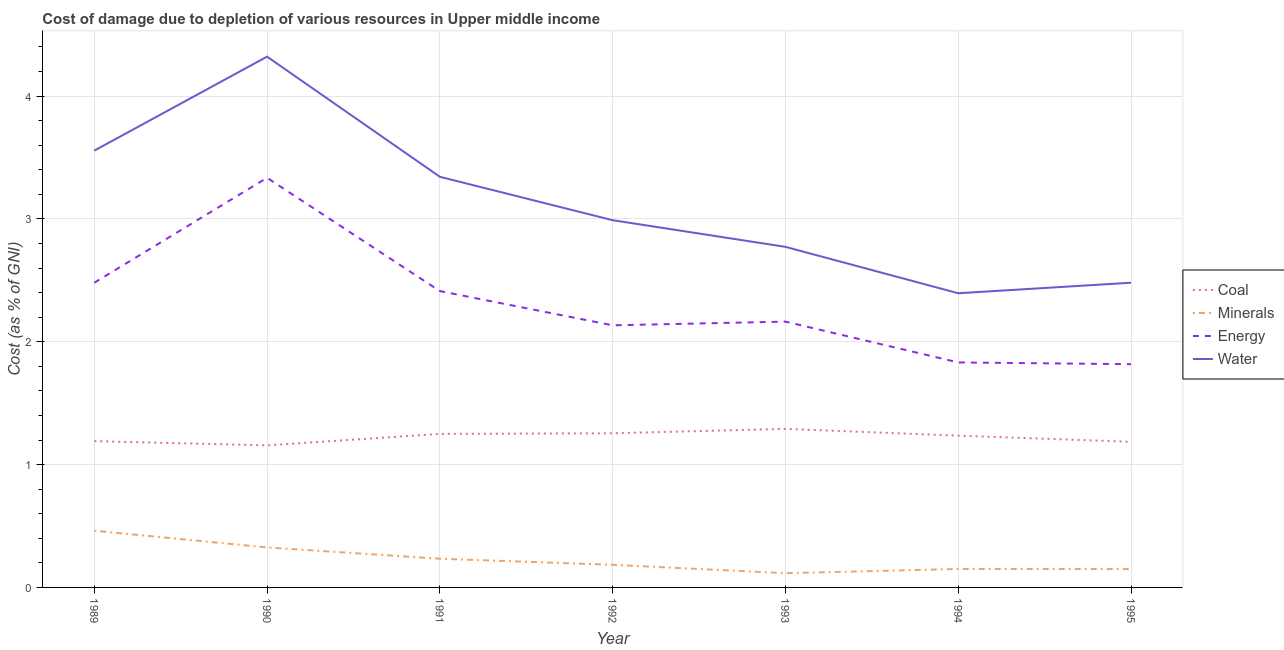Does the line corresponding to cost of damage due to depletion of water intersect with the line corresponding to cost of damage due to depletion of energy?
Give a very brief answer. No. Is the number of lines equal to the number of legend labels?
Offer a terse response. Yes. What is the cost of damage due to depletion of energy in 1994?
Your answer should be very brief. 1.83. Across all years, what is the maximum cost of damage due to depletion of water?
Your response must be concise. 4.32. Across all years, what is the minimum cost of damage due to depletion of coal?
Offer a very short reply. 1.16. In which year was the cost of damage due to depletion of energy maximum?
Your answer should be very brief. 1990. In which year was the cost of damage due to depletion of coal minimum?
Provide a succinct answer. 1990. What is the total cost of damage due to depletion of water in the graph?
Provide a short and direct response. 21.86. What is the difference between the cost of damage due to depletion of coal in 1989 and that in 1993?
Offer a very short reply. -0.1. What is the difference between the cost of damage due to depletion of coal in 1989 and the cost of damage due to depletion of minerals in 1991?
Keep it short and to the point. 0.96. What is the average cost of damage due to depletion of energy per year?
Provide a succinct answer. 2.31. In the year 1993, what is the difference between the cost of damage due to depletion of coal and cost of damage due to depletion of minerals?
Provide a short and direct response. 1.17. In how many years, is the cost of damage due to depletion of minerals greater than 0.2 %?
Offer a terse response. 3. What is the ratio of the cost of damage due to depletion of coal in 1989 to that in 1994?
Your answer should be compact. 0.96. What is the difference between the highest and the second highest cost of damage due to depletion of energy?
Offer a very short reply. 0.85. What is the difference between the highest and the lowest cost of damage due to depletion of energy?
Offer a terse response. 1.52. In how many years, is the cost of damage due to depletion of energy greater than the average cost of damage due to depletion of energy taken over all years?
Keep it short and to the point. 3. Is it the case that in every year, the sum of the cost of damage due to depletion of coal and cost of damage due to depletion of minerals is greater than the cost of damage due to depletion of energy?
Your answer should be compact. No. Does the cost of damage due to depletion of minerals monotonically increase over the years?
Provide a succinct answer. No. Is the cost of damage due to depletion of coal strictly less than the cost of damage due to depletion of energy over the years?
Your answer should be very brief. Yes. How many lines are there?
Ensure brevity in your answer.  4. How many years are there in the graph?
Your response must be concise. 7. Are the values on the major ticks of Y-axis written in scientific E-notation?
Give a very brief answer. No. Does the graph contain grids?
Your answer should be very brief. Yes. Where does the legend appear in the graph?
Your answer should be very brief. Center right. What is the title of the graph?
Provide a succinct answer. Cost of damage due to depletion of various resources in Upper middle income . Does "Insurance services" appear as one of the legend labels in the graph?
Your answer should be very brief. No. What is the label or title of the X-axis?
Offer a terse response. Year. What is the label or title of the Y-axis?
Provide a short and direct response. Cost (as % of GNI). What is the Cost (as % of GNI) of Coal in 1989?
Your answer should be very brief. 1.19. What is the Cost (as % of GNI) in Minerals in 1989?
Your answer should be very brief. 0.46. What is the Cost (as % of GNI) of Energy in 1989?
Your answer should be very brief. 2.48. What is the Cost (as % of GNI) of Water in 1989?
Your response must be concise. 3.56. What is the Cost (as % of GNI) of Coal in 1990?
Offer a very short reply. 1.16. What is the Cost (as % of GNI) in Minerals in 1990?
Ensure brevity in your answer.  0.33. What is the Cost (as % of GNI) in Energy in 1990?
Your answer should be very brief. 3.33. What is the Cost (as % of GNI) of Water in 1990?
Your answer should be compact. 4.32. What is the Cost (as % of GNI) of Coal in 1991?
Your answer should be very brief. 1.25. What is the Cost (as % of GNI) of Minerals in 1991?
Make the answer very short. 0.23. What is the Cost (as % of GNI) in Energy in 1991?
Give a very brief answer. 2.41. What is the Cost (as % of GNI) of Water in 1991?
Provide a succinct answer. 3.34. What is the Cost (as % of GNI) in Coal in 1992?
Ensure brevity in your answer.  1.26. What is the Cost (as % of GNI) in Minerals in 1992?
Offer a terse response. 0.18. What is the Cost (as % of GNI) of Energy in 1992?
Make the answer very short. 2.13. What is the Cost (as % of GNI) of Water in 1992?
Ensure brevity in your answer.  2.99. What is the Cost (as % of GNI) of Coal in 1993?
Provide a short and direct response. 1.29. What is the Cost (as % of GNI) of Minerals in 1993?
Offer a terse response. 0.12. What is the Cost (as % of GNI) in Energy in 1993?
Your answer should be compact. 2.16. What is the Cost (as % of GNI) of Water in 1993?
Make the answer very short. 2.77. What is the Cost (as % of GNI) of Coal in 1994?
Keep it short and to the point. 1.24. What is the Cost (as % of GNI) in Minerals in 1994?
Provide a succinct answer. 0.15. What is the Cost (as % of GNI) of Energy in 1994?
Ensure brevity in your answer.  1.83. What is the Cost (as % of GNI) of Water in 1994?
Provide a succinct answer. 2.39. What is the Cost (as % of GNI) in Coal in 1995?
Provide a short and direct response. 1.19. What is the Cost (as % of GNI) in Minerals in 1995?
Your answer should be very brief. 0.15. What is the Cost (as % of GNI) in Energy in 1995?
Your answer should be very brief. 1.82. What is the Cost (as % of GNI) in Water in 1995?
Your answer should be compact. 2.48. Across all years, what is the maximum Cost (as % of GNI) in Coal?
Provide a short and direct response. 1.29. Across all years, what is the maximum Cost (as % of GNI) of Minerals?
Make the answer very short. 0.46. Across all years, what is the maximum Cost (as % of GNI) in Energy?
Ensure brevity in your answer.  3.33. Across all years, what is the maximum Cost (as % of GNI) of Water?
Offer a terse response. 4.32. Across all years, what is the minimum Cost (as % of GNI) in Coal?
Your response must be concise. 1.16. Across all years, what is the minimum Cost (as % of GNI) of Minerals?
Make the answer very short. 0.12. Across all years, what is the minimum Cost (as % of GNI) of Energy?
Keep it short and to the point. 1.82. Across all years, what is the minimum Cost (as % of GNI) in Water?
Ensure brevity in your answer.  2.39. What is the total Cost (as % of GNI) in Coal in the graph?
Your answer should be compact. 8.56. What is the total Cost (as % of GNI) in Minerals in the graph?
Make the answer very short. 1.62. What is the total Cost (as % of GNI) of Energy in the graph?
Keep it short and to the point. 16.17. What is the total Cost (as % of GNI) in Water in the graph?
Your answer should be compact. 21.86. What is the difference between the Cost (as % of GNI) of Coal in 1989 and that in 1990?
Provide a short and direct response. 0.03. What is the difference between the Cost (as % of GNI) in Minerals in 1989 and that in 1990?
Your answer should be very brief. 0.14. What is the difference between the Cost (as % of GNI) of Energy in 1989 and that in 1990?
Keep it short and to the point. -0.85. What is the difference between the Cost (as % of GNI) in Water in 1989 and that in 1990?
Your response must be concise. -0.77. What is the difference between the Cost (as % of GNI) of Coal in 1989 and that in 1991?
Ensure brevity in your answer.  -0.06. What is the difference between the Cost (as % of GNI) in Minerals in 1989 and that in 1991?
Your answer should be very brief. 0.23. What is the difference between the Cost (as % of GNI) of Energy in 1989 and that in 1991?
Your answer should be very brief. 0.07. What is the difference between the Cost (as % of GNI) of Water in 1989 and that in 1991?
Keep it short and to the point. 0.21. What is the difference between the Cost (as % of GNI) in Coal in 1989 and that in 1992?
Give a very brief answer. -0.06. What is the difference between the Cost (as % of GNI) in Minerals in 1989 and that in 1992?
Your response must be concise. 0.28. What is the difference between the Cost (as % of GNI) of Energy in 1989 and that in 1992?
Offer a terse response. 0.35. What is the difference between the Cost (as % of GNI) of Water in 1989 and that in 1992?
Your answer should be very brief. 0.57. What is the difference between the Cost (as % of GNI) in Coal in 1989 and that in 1993?
Provide a succinct answer. -0.1. What is the difference between the Cost (as % of GNI) in Minerals in 1989 and that in 1993?
Offer a very short reply. 0.35. What is the difference between the Cost (as % of GNI) in Energy in 1989 and that in 1993?
Offer a very short reply. 0.32. What is the difference between the Cost (as % of GNI) of Water in 1989 and that in 1993?
Your answer should be compact. 0.78. What is the difference between the Cost (as % of GNI) in Coal in 1989 and that in 1994?
Your answer should be very brief. -0.04. What is the difference between the Cost (as % of GNI) of Minerals in 1989 and that in 1994?
Ensure brevity in your answer.  0.31. What is the difference between the Cost (as % of GNI) of Energy in 1989 and that in 1994?
Ensure brevity in your answer.  0.65. What is the difference between the Cost (as % of GNI) in Water in 1989 and that in 1994?
Offer a terse response. 1.16. What is the difference between the Cost (as % of GNI) in Coal in 1989 and that in 1995?
Provide a short and direct response. 0.01. What is the difference between the Cost (as % of GNI) in Minerals in 1989 and that in 1995?
Offer a terse response. 0.31. What is the difference between the Cost (as % of GNI) of Energy in 1989 and that in 1995?
Offer a very short reply. 0.66. What is the difference between the Cost (as % of GNI) of Water in 1989 and that in 1995?
Provide a short and direct response. 1.08. What is the difference between the Cost (as % of GNI) in Coal in 1990 and that in 1991?
Provide a succinct answer. -0.09. What is the difference between the Cost (as % of GNI) in Minerals in 1990 and that in 1991?
Keep it short and to the point. 0.09. What is the difference between the Cost (as % of GNI) in Energy in 1990 and that in 1991?
Provide a short and direct response. 0.92. What is the difference between the Cost (as % of GNI) of Coal in 1990 and that in 1992?
Your answer should be compact. -0.1. What is the difference between the Cost (as % of GNI) in Minerals in 1990 and that in 1992?
Keep it short and to the point. 0.14. What is the difference between the Cost (as % of GNI) of Energy in 1990 and that in 1992?
Your answer should be very brief. 1.2. What is the difference between the Cost (as % of GNI) in Water in 1990 and that in 1992?
Your answer should be compact. 1.33. What is the difference between the Cost (as % of GNI) of Coal in 1990 and that in 1993?
Offer a very short reply. -0.13. What is the difference between the Cost (as % of GNI) of Minerals in 1990 and that in 1993?
Make the answer very short. 0.21. What is the difference between the Cost (as % of GNI) in Energy in 1990 and that in 1993?
Your response must be concise. 1.17. What is the difference between the Cost (as % of GNI) of Water in 1990 and that in 1993?
Your answer should be compact. 1.55. What is the difference between the Cost (as % of GNI) of Coal in 1990 and that in 1994?
Ensure brevity in your answer.  -0.08. What is the difference between the Cost (as % of GNI) in Minerals in 1990 and that in 1994?
Give a very brief answer. 0.18. What is the difference between the Cost (as % of GNI) in Energy in 1990 and that in 1994?
Provide a short and direct response. 1.5. What is the difference between the Cost (as % of GNI) in Water in 1990 and that in 1994?
Provide a short and direct response. 1.93. What is the difference between the Cost (as % of GNI) of Coal in 1990 and that in 1995?
Give a very brief answer. -0.03. What is the difference between the Cost (as % of GNI) of Minerals in 1990 and that in 1995?
Offer a terse response. 0.18. What is the difference between the Cost (as % of GNI) in Energy in 1990 and that in 1995?
Ensure brevity in your answer.  1.52. What is the difference between the Cost (as % of GNI) in Water in 1990 and that in 1995?
Offer a very short reply. 1.84. What is the difference between the Cost (as % of GNI) in Coal in 1991 and that in 1992?
Offer a very short reply. -0.01. What is the difference between the Cost (as % of GNI) of Minerals in 1991 and that in 1992?
Your answer should be compact. 0.05. What is the difference between the Cost (as % of GNI) in Energy in 1991 and that in 1992?
Offer a very short reply. 0.28. What is the difference between the Cost (as % of GNI) of Water in 1991 and that in 1992?
Keep it short and to the point. 0.35. What is the difference between the Cost (as % of GNI) in Coal in 1991 and that in 1993?
Make the answer very short. -0.04. What is the difference between the Cost (as % of GNI) of Minerals in 1991 and that in 1993?
Ensure brevity in your answer.  0.12. What is the difference between the Cost (as % of GNI) of Energy in 1991 and that in 1993?
Your answer should be compact. 0.25. What is the difference between the Cost (as % of GNI) of Water in 1991 and that in 1993?
Your answer should be very brief. 0.57. What is the difference between the Cost (as % of GNI) of Coal in 1991 and that in 1994?
Ensure brevity in your answer.  0.01. What is the difference between the Cost (as % of GNI) of Minerals in 1991 and that in 1994?
Offer a terse response. 0.08. What is the difference between the Cost (as % of GNI) in Energy in 1991 and that in 1994?
Provide a short and direct response. 0.58. What is the difference between the Cost (as % of GNI) of Water in 1991 and that in 1994?
Provide a succinct answer. 0.95. What is the difference between the Cost (as % of GNI) of Coal in 1991 and that in 1995?
Your answer should be very brief. 0.06. What is the difference between the Cost (as % of GNI) in Minerals in 1991 and that in 1995?
Your response must be concise. 0.08. What is the difference between the Cost (as % of GNI) in Energy in 1991 and that in 1995?
Provide a succinct answer. 0.6. What is the difference between the Cost (as % of GNI) in Water in 1991 and that in 1995?
Your response must be concise. 0.86. What is the difference between the Cost (as % of GNI) in Coal in 1992 and that in 1993?
Your answer should be very brief. -0.04. What is the difference between the Cost (as % of GNI) in Minerals in 1992 and that in 1993?
Offer a very short reply. 0.07. What is the difference between the Cost (as % of GNI) of Energy in 1992 and that in 1993?
Provide a short and direct response. -0.03. What is the difference between the Cost (as % of GNI) in Water in 1992 and that in 1993?
Keep it short and to the point. 0.22. What is the difference between the Cost (as % of GNI) of Coal in 1992 and that in 1994?
Offer a very short reply. 0.02. What is the difference between the Cost (as % of GNI) of Minerals in 1992 and that in 1994?
Your answer should be very brief. 0.03. What is the difference between the Cost (as % of GNI) of Energy in 1992 and that in 1994?
Provide a succinct answer. 0.3. What is the difference between the Cost (as % of GNI) of Water in 1992 and that in 1994?
Your answer should be very brief. 0.59. What is the difference between the Cost (as % of GNI) in Coal in 1992 and that in 1995?
Give a very brief answer. 0.07. What is the difference between the Cost (as % of GNI) of Minerals in 1992 and that in 1995?
Offer a very short reply. 0.03. What is the difference between the Cost (as % of GNI) in Energy in 1992 and that in 1995?
Ensure brevity in your answer.  0.32. What is the difference between the Cost (as % of GNI) in Water in 1992 and that in 1995?
Your answer should be very brief. 0.51. What is the difference between the Cost (as % of GNI) of Coal in 1993 and that in 1994?
Give a very brief answer. 0.06. What is the difference between the Cost (as % of GNI) of Minerals in 1993 and that in 1994?
Provide a succinct answer. -0.03. What is the difference between the Cost (as % of GNI) in Energy in 1993 and that in 1994?
Make the answer very short. 0.33. What is the difference between the Cost (as % of GNI) in Water in 1993 and that in 1994?
Offer a very short reply. 0.38. What is the difference between the Cost (as % of GNI) in Coal in 1993 and that in 1995?
Offer a terse response. 0.11. What is the difference between the Cost (as % of GNI) of Minerals in 1993 and that in 1995?
Keep it short and to the point. -0.03. What is the difference between the Cost (as % of GNI) in Energy in 1993 and that in 1995?
Give a very brief answer. 0.35. What is the difference between the Cost (as % of GNI) of Water in 1993 and that in 1995?
Offer a terse response. 0.29. What is the difference between the Cost (as % of GNI) in Coal in 1994 and that in 1995?
Make the answer very short. 0.05. What is the difference between the Cost (as % of GNI) of Minerals in 1994 and that in 1995?
Your response must be concise. 0. What is the difference between the Cost (as % of GNI) of Energy in 1994 and that in 1995?
Your answer should be compact. 0.01. What is the difference between the Cost (as % of GNI) of Water in 1994 and that in 1995?
Your answer should be compact. -0.09. What is the difference between the Cost (as % of GNI) of Coal in 1989 and the Cost (as % of GNI) of Minerals in 1990?
Provide a short and direct response. 0.87. What is the difference between the Cost (as % of GNI) in Coal in 1989 and the Cost (as % of GNI) in Energy in 1990?
Keep it short and to the point. -2.14. What is the difference between the Cost (as % of GNI) of Coal in 1989 and the Cost (as % of GNI) of Water in 1990?
Keep it short and to the point. -3.13. What is the difference between the Cost (as % of GNI) of Minerals in 1989 and the Cost (as % of GNI) of Energy in 1990?
Offer a terse response. -2.87. What is the difference between the Cost (as % of GNI) of Minerals in 1989 and the Cost (as % of GNI) of Water in 1990?
Offer a very short reply. -3.86. What is the difference between the Cost (as % of GNI) of Energy in 1989 and the Cost (as % of GNI) of Water in 1990?
Your answer should be very brief. -1.84. What is the difference between the Cost (as % of GNI) in Coal in 1989 and the Cost (as % of GNI) in Minerals in 1991?
Give a very brief answer. 0.96. What is the difference between the Cost (as % of GNI) in Coal in 1989 and the Cost (as % of GNI) in Energy in 1991?
Ensure brevity in your answer.  -1.22. What is the difference between the Cost (as % of GNI) of Coal in 1989 and the Cost (as % of GNI) of Water in 1991?
Provide a short and direct response. -2.15. What is the difference between the Cost (as % of GNI) of Minerals in 1989 and the Cost (as % of GNI) of Energy in 1991?
Your response must be concise. -1.95. What is the difference between the Cost (as % of GNI) in Minerals in 1989 and the Cost (as % of GNI) in Water in 1991?
Your answer should be very brief. -2.88. What is the difference between the Cost (as % of GNI) in Energy in 1989 and the Cost (as % of GNI) in Water in 1991?
Your answer should be very brief. -0.86. What is the difference between the Cost (as % of GNI) of Coal in 1989 and the Cost (as % of GNI) of Minerals in 1992?
Give a very brief answer. 1.01. What is the difference between the Cost (as % of GNI) in Coal in 1989 and the Cost (as % of GNI) in Energy in 1992?
Offer a very short reply. -0.94. What is the difference between the Cost (as % of GNI) in Coal in 1989 and the Cost (as % of GNI) in Water in 1992?
Your answer should be compact. -1.8. What is the difference between the Cost (as % of GNI) of Minerals in 1989 and the Cost (as % of GNI) of Energy in 1992?
Your answer should be very brief. -1.67. What is the difference between the Cost (as % of GNI) of Minerals in 1989 and the Cost (as % of GNI) of Water in 1992?
Offer a terse response. -2.53. What is the difference between the Cost (as % of GNI) of Energy in 1989 and the Cost (as % of GNI) of Water in 1992?
Keep it short and to the point. -0.51. What is the difference between the Cost (as % of GNI) in Coal in 1989 and the Cost (as % of GNI) in Minerals in 1993?
Keep it short and to the point. 1.07. What is the difference between the Cost (as % of GNI) in Coal in 1989 and the Cost (as % of GNI) in Energy in 1993?
Your answer should be compact. -0.97. What is the difference between the Cost (as % of GNI) in Coal in 1989 and the Cost (as % of GNI) in Water in 1993?
Your answer should be compact. -1.58. What is the difference between the Cost (as % of GNI) of Minerals in 1989 and the Cost (as % of GNI) of Energy in 1993?
Make the answer very short. -1.7. What is the difference between the Cost (as % of GNI) of Minerals in 1989 and the Cost (as % of GNI) of Water in 1993?
Give a very brief answer. -2.31. What is the difference between the Cost (as % of GNI) of Energy in 1989 and the Cost (as % of GNI) of Water in 1993?
Provide a short and direct response. -0.29. What is the difference between the Cost (as % of GNI) of Coal in 1989 and the Cost (as % of GNI) of Minerals in 1994?
Keep it short and to the point. 1.04. What is the difference between the Cost (as % of GNI) in Coal in 1989 and the Cost (as % of GNI) in Energy in 1994?
Make the answer very short. -0.64. What is the difference between the Cost (as % of GNI) in Coal in 1989 and the Cost (as % of GNI) in Water in 1994?
Your answer should be very brief. -1.2. What is the difference between the Cost (as % of GNI) of Minerals in 1989 and the Cost (as % of GNI) of Energy in 1994?
Your response must be concise. -1.37. What is the difference between the Cost (as % of GNI) of Minerals in 1989 and the Cost (as % of GNI) of Water in 1994?
Give a very brief answer. -1.93. What is the difference between the Cost (as % of GNI) in Energy in 1989 and the Cost (as % of GNI) in Water in 1994?
Provide a succinct answer. 0.09. What is the difference between the Cost (as % of GNI) in Coal in 1989 and the Cost (as % of GNI) in Minerals in 1995?
Offer a very short reply. 1.04. What is the difference between the Cost (as % of GNI) in Coal in 1989 and the Cost (as % of GNI) in Energy in 1995?
Your answer should be very brief. -0.63. What is the difference between the Cost (as % of GNI) in Coal in 1989 and the Cost (as % of GNI) in Water in 1995?
Make the answer very short. -1.29. What is the difference between the Cost (as % of GNI) of Minerals in 1989 and the Cost (as % of GNI) of Energy in 1995?
Provide a succinct answer. -1.36. What is the difference between the Cost (as % of GNI) of Minerals in 1989 and the Cost (as % of GNI) of Water in 1995?
Offer a very short reply. -2.02. What is the difference between the Cost (as % of GNI) in Energy in 1989 and the Cost (as % of GNI) in Water in 1995?
Make the answer very short. -0. What is the difference between the Cost (as % of GNI) of Coal in 1990 and the Cost (as % of GNI) of Minerals in 1991?
Keep it short and to the point. 0.92. What is the difference between the Cost (as % of GNI) in Coal in 1990 and the Cost (as % of GNI) in Energy in 1991?
Offer a terse response. -1.26. What is the difference between the Cost (as % of GNI) of Coal in 1990 and the Cost (as % of GNI) of Water in 1991?
Make the answer very short. -2.19. What is the difference between the Cost (as % of GNI) in Minerals in 1990 and the Cost (as % of GNI) in Energy in 1991?
Provide a short and direct response. -2.09. What is the difference between the Cost (as % of GNI) in Minerals in 1990 and the Cost (as % of GNI) in Water in 1991?
Offer a terse response. -3.02. What is the difference between the Cost (as % of GNI) of Energy in 1990 and the Cost (as % of GNI) of Water in 1991?
Keep it short and to the point. -0.01. What is the difference between the Cost (as % of GNI) of Coal in 1990 and the Cost (as % of GNI) of Minerals in 1992?
Offer a terse response. 0.97. What is the difference between the Cost (as % of GNI) in Coal in 1990 and the Cost (as % of GNI) in Energy in 1992?
Keep it short and to the point. -0.98. What is the difference between the Cost (as % of GNI) of Coal in 1990 and the Cost (as % of GNI) of Water in 1992?
Provide a succinct answer. -1.83. What is the difference between the Cost (as % of GNI) of Minerals in 1990 and the Cost (as % of GNI) of Energy in 1992?
Your answer should be very brief. -1.81. What is the difference between the Cost (as % of GNI) in Minerals in 1990 and the Cost (as % of GNI) in Water in 1992?
Provide a short and direct response. -2.66. What is the difference between the Cost (as % of GNI) of Energy in 1990 and the Cost (as % of GNI) of Water in 1992?
Offer a terse response. 0.35. What is the difference between the Cost (as % of GNI) of Coal in 1990 and the Cost (as % of GNI) of Minerals in 1993?
Your answer should be compact. 1.04. What is the difference between the Cost (as % of GNI) in Coal in 1990 and the Cost (as % of GNI) in Energy in 1993?
Ensure brevity in your answer.  -1.01. What is the difference between the Cost (as % of GNI) in Coal in 1990 and the Cost (as % of GNI) in Water in 1993?
Ensure brevity in your answer.  -1.62. What is the difference between the Cost (as % of GNI) in Minerals in 1990 and the Cost (as % of GNI) in Energy in 1993?
Your answer should be very brief. -1.84. What is the difference between the Cost (as % of GNI) of Minerals in 1990 and the Cost (as % of GNI) of Water in 1993?
Provide a succinct answer. -2.45. What is the difference between the Cost (as % of GNI) in Energy in 1990 and the Cost (as % of GNI) in Water in 1993?
Keep it short and to the point. 0.56. What is the difference between the Cost (as % of GNI) of Coal in 1990 and the Cost (as % of GNI) of Minerals in 1994?
Ensure brevity in your answer.  1.01. What is the difference between the Cost (as % of GNI) in Coal in 1990 and the Cost (as % of GNI) in Energy in 1994?
Make the answer very short. -0.68. What is the difference between the Cost (as % of GNI) of Coal in 1990 and the Cost (as % of GNI) of Water in 1994?
Give a very brief answer. -1.24. What is the difference between the Cost (as % of GNI) in Minerals in 1990 and the Cost (as % of GNI) in Energy in 1994?
Your answer should be very brief. -1.51. What is the difference between the Cost (as % of GNI) in Minerals in 1990 and the Cost (as % of GNI) in Water in 1994?
Keep it short and to the point. -2.07. What is the difference between the Cost (as % of GNI) of Energy in 1990 and the Cost (as % of GNI) of Water in 1994?
Give a very brief answer. 0.94. What is the difference between the Cost (as % of GNI) in Coal in 1990 and the Cost (as % of GNI) in Minerals in 1995?
Make the answer very short. 1.01. What is the difference between the Cost (as % of GNI) in Coal in 1990 and the Cost (as % of GNI) in Energy in 1995?
Your answer should be compact. -0.66. What is the difference between the Cost (as % of GNI) of Coal in 1990 and the Cost (as % of GNI) of Water in 1995?
Your answer should be very brief. -1.32. What is the difference between the Cost (as % of GNI) in Minerals in 1990 and the Cost (as % of GNI) in Energy in 1995?
Offer a terse response. -1.49. What is the difference between the Cost (as % of GNI) in Minerals in 1990 and the Cost (as % of GNI) in Water in 1995?
Offer a very short reply. -2.16. What is the difference between the Cost (as % of GNI) of Energy in 1990 and the Cost (as % of GNI) of Water in 1995?
Your answer should be compact. 0.85. What is the difference between the Cost (as % of GNI) in Coal in 1991 and the Cost (as % of GNI) in Minerals in 1992?
Your answer should be very brief. 1.07. What is the difference between the Cost (as % of GNI) in Coal in 1991 and the Cost (as % of GNI) in Energy in 1992?
Offer a very short reply. -0.88. What is the difference between the Cost (as % of GNI) of Coal in 1991 and the Cost (as % of GNI) of Water in 1992?
Give a very brief answer. -1.74. What is the difference between the Cost (as % of GNI) in Minerals in 1991 and the Cost (as % of GNI) in Energy in 1992?
Make the answer very short. -1.9. What is the difference between the Cost (as % of GNI) in Minerals in 1991 and the Cost (as % of GNI) in Water in 1992?
Keep it short and to the point. -2.76. What is the difference between the Cost (as % of GNI) in Energy in 1991 and the Cost (as % of GNI) in Water in 1992?
Offer a very short reply. -0.58. What is the difference between the Cost (as % of GNI) in Coal in 1991 and the Cost (as % of GNI) in Minerals in 1993?
Offer a very short reply. 1.13. What is the difference between the Cost (as % of GNI) of Coal in 1991 and the Cost (as % of GNI) of Energy in 1993?
Your answer should be compact. -0.91. What is the difference between the Cost (as % of GNI) of Coal in 1991 and the Cost (as % of GNI) of Water in 1993?
Make the answer very short. -1.52. What is the difference between the Cost (as % of GNI) in Minerals in 1991 and the Cost (as % of GNI) in Energy in 1993?
Your answer should be compact. -1.93. What is the difference between the Cost (as % of GNI) in Minerals in 1991 and the Cost (as % of GNI) in Water in 1993?
Ensure brevity in your answer.  -2.54. What is the difference between the Cost (as % of GNI) of Energy in 1991 and the Cost (as % of GNI) of Water in 1993?
Make the answer very short. -0.36. What is the difference between the Cost (as % of GNI) of Coal in 1991 and the Cost (as % of GNI) of Minerals in 1994?
Make the answer very short. 1.1. What is the difference between the Cost (as % of GNI) in Coal in 1991 and the Cost (as % of GNI) in Energy in 1994?
Provide a short and direct response. -0.58. What is the difference between the Cost (as % of GNI) of Coal in 1991 and the Cost (as % of GNI) of Water in 1994?
Make the answer very short. -1.15. What is the difference between the Cost (as % of GNI) in Minerals in 1991 and the Cost (as % of GNI) in Energy in 1994?
Give a very brief answer. -1.6. What is the difference between the Cost (as % of GNI) of Minerals in 1991 and the Cost (as % of GNI) of Water in 1994?
Offer a very short reply. -2.16. What is the difference between the Cost (as % of GNI) of Energy in 1991 and the Cost (as % of GNI) of Water in 1994?
Make the answer very short. 0.02. What is the difference between the Cost (as % of GNI) of Coal in 1991 and the Cost (as % of GNI) of Minerals in 1995?
Your response must be concise. 1.1. What is the difference between the Cost (as % of GNI) in Coal in 1991 and the Cost (as % of GNI) in Energy in 1995?
Your answer should be compact. -0.57. What is the difference between the Cost (as % of GNI) in Coal in 1991 and the Cost (as % of GNI) in Water in 1995?
Ensure brevity in your answer.  -1.23. What is the difference between the Cost (as % of GNI) in Minerals in 1991 and the Cost (as % of GNI) in Energy in 1995?
Your answer should be compact. -1.58. What is the difference between the Cost (as % of GNI) in Minerals in 1991 and the Cost (as % of GNI) in Water in 1995?
Your answer should be very brief. -2.25. What is the difference between the Cost (as % of GNI) of Energy in 1991 and the Cost (as % of GNI) of Water in 1995?
Offer a very short reply. -0.07. What is the difference between the Cost (as % of GNI) in Coal in 1992 and the Cost (as % of GNI) in Minerals in 1993?
Give a very brief answer. 1.14. What is the difference between the Cost (as % of GNI) of Coal in 1992 and the Cost (as % of GNI) of Energy in 1993?
Make the answer very short. -0.91. What is the difference between the Cost (as % of GNI) in Coal in 1992 and the Cost (as % of GNI) in Water in 1993?
Keep it short and to the point. -1.52. What is the difference between the Cost (as % of GNI) in Minerals in 1992 and the Cost (as % of GNI) in Energy in 1993?
Provide a short and direct response. -1.98. What is the difference between the Cost (as % of GNI) in Minerals in 1992 and the Cost (as % of GNI) in Water in 1993?
Your answer should be very brief. -2.59. What is the difference between the Cost (as % of GNI) of Energy in 1992 and the Cost (as % of GNI) of Water in 1993?
Give a very brief answer. -0.64. What is the difference between the Cost (as % of GNI) of Coal in 1992 and the Cost (as % of GNI) of Minerals in 1994?
Make the answer very short. 1.1. What is the difference between the Cost (as % of GNI) in Coal in 1992 and the Cost (as % of GNI) in Energy in 1994?
Ensure brevity in your answer.  -0.58. What is the difference between the Cost (as % of GNI) of Coal in 1992 and the Cost (as % of GNI) of Water in 1994?
Ensure brevity in your answer.  -1.14. What is the difference between the Cost (as % of GNI) in Minerals in 1992 and the Cost (as % of GNI) in Energy in 1994?
Your answer should be compact. -1.65. What is the difference between the Cost (as % of GNI) in Minerals in 1992 and the Cost (as % of GNI) in Water in 1994?
Your answer should be compact. -2.21. What is the difference between the Cost (as % of GNI) in Energy in 1992 and the Cost (as % of GNI) in Water in 1994?
Offer a terse response. -0.26. What is the difference between the Cost (as % of GNI) in Coal in 1992 and the Cost (as % of GNI) in Minerals in 1995?
Make the answer very short. 1.11. What is the difference between the Cost (as % of GNI) of Coal in 1992 and the Cost (as % of GNI) of Energy in 1995?
Offer a terse response. -0.56. What is the difference between the Cost (as % of GNI) in Coal in 1992 and the Cost (as % of GNI) in Water in 1995?
Provide a succinct answer. -1.23. What is the difference between the Cost (as % of GNI) in Minerals in 1992 and the Cost (as % of GNI) in Energy in 1995?
Provide a succinct answer. -1.63. What is the difference between the Cost (as % of GNI) of Minerals in 1992 and the Cost (as % of GNI) of Water in 1995?
Offer a very short reply. -2.3. What is the difference between the Cost (as % of GNI) in Energy in 1992 and the Cost (as % of GNI) in Water in 1995?
Provide a short and direct response. -0.35. What is the difference between the Cost (as % of GNI) in Coal in 1993 and the Cost (as % of GNI) in Minerals in 1994?
Ensure brevity in your answer.  1.14. What is the difference between the Cost (as % of GNI) in Coal in 1993 and the Cost (as % of GNI) in Energy in 1994?
Provide a short and direct response. -0.54. What is the difference between the Cost (as % of GNI) in Coal in 1993 and the Cost (as % of GNI) in Water in 1994?
Provide a short and direct response. -1.1. What is the difference between the Cost (as % of GNI) in Minerals in 1993 and the Cost (as % of GNI) in Energy in 1994?
Ensure brevity in your answer.  -1.72. What is the difference between the Cost (as % of GNI) in Minerals in 1993 and the Cost (as % of GNI) in Water in 1994?
Keep it short and to the point. -2.28. What is the difference between the Cost (as % of GNI) of Energy in 1993 and the Cost (as % of GNI) of Water in 1994?
Provide a short and direct response. -0.23. What is the difference between the Cost (as % of GNI) of Coal in 1993 and the Cost (as % of GNI) of Minerals in 1995?
Offer a terse response. 1.14. What is the difference between the Cost (as % of GNI) in Coal in 1993 and the Cost (as % of GNI) in Energy in 1995?
Keep it short and to the point. -0.53. What is the difference between the Cost (as % of GNI) in Coal in 1993 and the Cost (as % of GNI) in Water in 1995?
Offer a terse response. -1.19. What is the difference between the Cost (as % of GNI) of Minerals in 1993 and the Cost (as % of GNI) of Energy in 1995?
Keep it short and to the point. -1.7. What is the difference between the Cost (as % of GNI) in Minerals in 1993 and the Cost (as % of GNI) in Water in 1995?
Your answer should be compact. -2.36. What is the difference between the Cost (as % of GNI) of Energy in 1993 and the Cost (as % of GNI) of Water in 1995?
Your answer should be compact. -0.32. What is the difference between the Cost (as % of GNI) of Coal in 1994 and the Cost (as % of GNI) of Minerals in 1995?
Give a very brief answer. 1.09. What is the difference between the Cost (as % of GNI) of Coal in 1994 and the Cost (as % of GNI) of Energy in 1995?
Keep it short and to the point. -0.58. What is the difference between the Cost (as % of GNI) in Coal in 1994 and the Cost (as % of GNI) in Water in 1995?
Your response must be concise. -1.25. What is the difference between the Cost (as % of GNI) in Minerals in 1994 and the Cost (as % of GNI) in Energy in 1995?
Your answer should be very brief. -1.67. What is the difference between the Cost (as % of GNI) in Minerals in 1994 and the Cost (as % of GNI) in Water in 1995?
Give a very brief answer. -2.33. What is the difference between the Cost (as % of GNI) in Energy in 1994 and the Cost (as % of GNI) in Water in 1995?
Offer a very short reply. -0.65. What is the average Cost (as % of GNI) of Coal per year?
Your answer should be very brief. 1.22. What is the average Cost (as % of GNI) in Minerals per year?
Provide a succinct answer. 0.23. What is the average Cost (as % of GNI) in Energy per year?
Your answer should be very brief. 2.31. What is the average Cost (as % of GNI) in Water per year?
Make the answer very short. 3.12. In the year 1989, what is the difference between the Cost (as % of GNI) of Coal and Cost (as % of GNI) of Minerals?
Your response must be concise. 0.73. In the year 1989, what is the difference between the Cost (as % of GNI) of Coal and Cost (as % of GNI) of Energy?
Provide a succinct answer. -1.29. In the year 1989, what is the difference between the Cost (as % of GNI) of Coal and Cost (as % of GNI) of Water?
Offer a terse response. -2.36. In the year 1989, what is the difference between the Cost (as % of GNI) of Minerals and Cost (as % of GNI) of Energy?
Your answer should be compact. -2.02. In the year 1989, what is the difference between the Cost (as % of GNI) in Minerals and Cost (as % of GNI) in Water?
Provide a succinct answer. -3.09. In the year 1989, what is the difference between the Cost (as % of GNI) of Energy and Cost (as % of GNI) of Water?
Keep it short and to the point. -1.08. In the year 1990, what is the difference between the Cost (as % of GNI) of Coal and Cost (as % of GNI) of Minerals?
Provide a succinct answer. 0.83. In the year 1990, what is the difference between the Cost (as % of GNI) in Coal and Cost (as % of GNI) in Energy?
Keep it short and to the point. -2.18. In the year 1990, what is the difference between the Cost (as % of GNI) in Coal and Cost (as % of GNI) in Water?
Make the answer very short. -3.16. In the year 1990, what is the difference between the Cost (as % of GNI) of Minerals and Cost (as % of GNI) of Energy?
Provide a short and direct response. -3.01. In the year 1990, what is the difference between the Cost (as % of GNI) in Minerals and Cost (as % of GNI) in Water?
Provide a succinct answer. -4. In the year 1990, what is the difference between the Cost (as % of GNI) of Energy and Cost (as % of GNI) of Water?
Your answer should be very brief. -0.99. In the year 1991, what is the difference between the Cost (as % of GNI) of Coal and Cost (as % of GNI) of Minerals?
Offer a very short reply. 1.02. In the year 1991, what is the difference between the Cost (as % of GNI) in Coal and Cost (as % of GNI) in Energy?
Your response must be concise. -1.16. In the year 1991, what is the difference between the Cost (as % of GNI) of Coal and Cost (as % of GNI) of Water?
Your answer should be very brief. -2.09. In the year 1991, what is the difference between the Cost (as % of GNI) in Minerals and Cost (as % of GNI) in Energy?
Offer a very short reply. -2.18. In the year 1991, what is the difference between the Cost (as % of GNI) of Minerals and Cost (as % of GNI) of Water?
Provide a short and direct response. -3.11. In the year 1991, what is the difference between the Cost (as % of GNI) in Energy and Cost (as % of GNI) in Water?
Your answer should be very brief. -0.93. In the year 1992, what is the difference between the Cost (as % of GNI) of Coal and Cost (as % of GNI) of Minerals?
Provide a short and direct response. 1.07. In the year 1992, what is the difference between the Cost (as % of GNI) of Coal and Cost (as % of GNI) of Energy?
Offer a terse response. -0.88. In the year 1992, what is the difference between the Cost (as % of GNI) of Coal and Cost (as % of GNI) of Water?
Keep it short and to the point. -1.73. In the year 1992, what is the difference between the Cost (as % of GNI) of Minerals and Cost (as % of GNI) of Energy?
Give a very brief answer. -1.95. In the year 1992, what is the difference between the Cost (as % of GNI) in Minerals and Cost (as % of GNI) in Water?
Your response must be concise. -2.81. In the year 1992, what is the difference between the Cost (as % of GNI) in Energy and Cost (as % of GNI) in Water?
Your answer should be very brief. -0.86. In the year 1993, what is the difference between the Cost (as % of GNI) in Coal and Cost (as % of GNI) in Minerals?
Make the answer very short. 1.17. In the year 1993, what is the difference between the Cost (as % of GNI) of Coal and Cost (as % of GNI) of Energy?
Your answer should be compact. -0.87. In the year 1993, what is the difference between the Cost (as % of GNI) in Coal and Cost (as % of GNI) in Water?
Your answer should be very brief. -1.48. In the year 1993, what is the difference between the Cost (as % of GNI) of Minerals and Cost (as % of GNI) of Energy?
Offer a terse response. -2.05. In the year 1993, what is the difference between the Cost (as % of GNI) in Minerals and Cost (as % of GNI) in Water?
Your answer should be compact. -2.66. In the year 1993, what is the difference between the Cost (as % of GNI) in Energy and Cost (as % of GNI) in Water?
Provide a succinct answer. -0.61. In the year 1994, what is the difference between the Cost (as % of GNI) in Coal and Cost (as % of GNI) in Minerals?
Ensure brevity in your answer.  1.09. In the year 1994, what is the difference between the Cost (as % of GNI) in Coal and Cost (as % of GNI) in Energy?
Keep it short and to the point. -0.6. In the year 1994, what is the difference between the Cost (as % of GNI) of Coal and Cost (as % of GNI) of Water?
Your answer should be very brief. -1.16. In the year 1994, what is the difference between the Cost (as % of GNI) of Minerals and Cost (as % of GNI) of Energy?
Your answer should be very brief. -1.68. In the year 1994, what is the difference between the Cost (as % of GNI) in Minerals and Cost (as % of GNI) in Water?
Your answer should be very brief. -2.24. In the year 1994, what is the difference between the Cost (as % of GNI) in Energy and Cost (as % of GNI) in Water?
Provide a short and direct response. -0.56. In the year 1995, what is the difference between the Cost (as % of GNI) in Coal and Cost (as % of GNI) in Minerals?
Your response must be concise. 1.04. In the year 1995, what is the difference between the Cost (as % of GNI) in Coal and Cost (as % of GNI) in Energy?
Provide a short and direct response. -0.63. In the year 1995, what is the difference between the Cost (as % of GNI) in Coal and Cost (as % of GNI) in Water?
Your answer should be very brief. -1.3. In the year 1995, what is the difference between the Cost (as % of GNI) of Minerals and Cost (as % of GNI) of Energy?
Provide a short and direct response. -1.67. In the year 1995, what is the difference between the Cost (as % of GNI) in Minerals and Cost (as % of GNI) in Water?
Give a very brief answer. -2.33. In the year 1995, what is the difference between the Cost (as % of GNI) in Energy and Cost (as % of GNI) in Water?
Provide a succinct answer. -0.66. What is the ratio of the Cost (as % of GNI) of Coal in 1989 to that in 1990?
Ensure brevity in your answer.  1.03. What is the ratio of the Cost (as % of GNI) of Minerals in 1989 to that in 1990?
Your response must be concise. 1.42. What is the ratio of the Cost (as % of GNI) of Energy in 1989 to that in 1990?
Your answer should be compact. 0.74. What is the ratio of the Cost (as % of GNI) of Water in 1989 to that in 1990?
Provide a succinct answer. 0.82. What is the ratio of the Cost (as % of GNI) of Coal in 1989 to that in 1991?
Provide a short and direct response. 0.95. What is the ratio of the Cost (as % of GNI) in Minerals in 1989 to that in 1991?
Provide a short and direct response. 1.98. What is the ratio of the Cost (as % of GNI) of Energy in 1989 to that in 1991?
Provide a succinct answer. 1.03. What is the ratio of the Cost (as % of GNI) in Water in 1989 to that in 1991?
Ensure brevity in your answer.  1.06. What is the ratio of the Cost (as % of GNI) of Coal in 1989 to that in 1992?
Your answer should be very brief. 0.95. What is the ratio of the Cost (as % of GNI) in Minerals in 1989 to that in 1992?
Your answer should be very brief. 2.51. What is the ratio of the Cost (as % of GNI) in Energy in 1989 to that in 1992?
Your answer should be very brief. 1.16. What is the ratio of the Cost (as % of GNI) in Water in 1989 to that in 1992?
Offer a terse response. 1.19. What is the ratio of the Cost (as % of GNI) of Coal in 1989 to that in 1993?
Keep it short and to the point. 0.92. What is the ratio of the Cost (as % of GNI) of Minerals in 1989 to that in 1993?
Provide a succinct answer. 3.98. What is the ratio of the Cost (as % of GNI) in Energy in 1989 to that in 1993?
Offer a very short reply. 1.15. What is the ratio of the Cost (as % of GNI) in Water in 1989 to that in 1993?
Your answer should be very brief. 1.28. What is the ratio of the Cost (as % of GNI) in Coal in 1989 to that in 1994?
Keep it short and to the point. 0.96. What is the ratio of the Cost (as % of GNI) of Minerals in 1989 to that in 1994?
Ensure brevity in your answer.  3.07. What is the ratio of the Cost (as % of GNI) in Energy in 1989 to that in 1994?
Your answer should be very brief. 1.35. What is the ratio of the Cost (as % of GNI) of Water in 1989 to that in 1994?
Make the answer very short. 1.48. What is the ratio of the Cost (as % of GNI) in Coal in 1989 to that in 1995?
Your response must be concise. 1. What is the ratio of the Cost (as % of GNI) in Minerals in 1989 to that in 1995?
Your answer should be compact. 3.09. What is the ratio of the Cost (as % of GNI) in Energy in 1989 to that in 1995?
Offer a terse response. 1.36. What is the ratio of the Cost (as % of GNI) in Water in 1989 to that in 1995?
Offer a very short reply. 1.43. What is the ratio of the Cost (as % of GNI) in Coal in 1990 to that in 1991?
Make the answer very short. 0.93. What is the ratio of the Cost (as % of GNI) in Minerals in 1990 to that in 1991?
Your answer should be very brief. 1.39. What is the ratio of the Cost (as % of GNI) in Energy in 1990 to that in 1991?
Keep it short and to the point. 1.38. What is the ratio of the Cost (as % of GNI) of Water in 1990 to that in 1991?
Your response must be concise. 1.29. What is the ratio of the Cost (as % of GNI) in Coal in 1990 to that in 1992?
Offer a terse response. 0.92. What is the ratio of the Cost (as % of GNI) of Minerals in 1990 to that in 1992?
Give a very brief answer. 1.77. What is the ratio of the Cost (as % of GNI) of Energy in 1990 to that in 1992?
Ensure brevity in your answer.  1.56. What is the ratio of the Cost (as % of GNI) in Water in 1990 to that in 1992?
Provide a succinct answer. 1.45. What is the ratio of the Cost (as % of GNI) of Coal in 1990 to that in 1993?
Ensure brevity in your answer.  0.9. What is the ratio of the Cost (as % of GNI) in Minerals in 1990 to that in 1993?
Provide a short and direct response. 2.81. What is the ratio of the Cost (as % of GNI) in Energy in 1990 to that in 1993?
Give a very brief answer. 1.54. What is the ratio of the Cost (as % of GNI) in Water in 1990 to that in 1993?
Provide a short and direct response. 1.56. What is the ratio of the Cost (as % of GNI) in Coal in 1990 to that in 1994?
Provide a short and direct response. 0.94. What is the ratio of the Cost (as % of GNI) in Minerals in 1990 to that in 1994?
Offer a very short reply. 2.17. What is the ratio of the Cost (as % of GNI) in Energy in 1990 to that in 1994?
Your answer should be very brief. 1.82. What is the ratio of the Cost (as % of GNI) in Water in 1990 to that in 1994?
Provide a succinct answer. 1.8. What is the ratio of the Cost (as % of GNI) in Coal in 1990 to that in 1995?
Your answer should be compact. 0.98. What is the ratio of the Cost (as % of GNI) in Minerals in 1990 to that in 1995?
Provide a succinct answer. 2.18. What is the ratio of the Cost (as % of GNI) in Energy in 1990 to that in 1995?
Make the answer very short. 1.83. What is the ratio of the Cost (as % of GNI) in Water in 1990 to that in 1995?
Your answer should be very brief. 1.74. What is the ratio of the Cost (as % of GNI) in Coal in 1991 to that in 1992?
Provide a succinct answer. 1. What is the ratio of the Cost (as % of GNI) of Minerals in 1991 to that in 1992?
Your answer should be very brief. 1.27. What is the ratio of the Cost (as % of GNI) of Energy in 1991 to that in 1992?
Provide a succinct answer. 1.13. What is the ratio of the Cost (as % of GNI) of Water in 1991 to that in 1992?
Give a very brief answer. 1.12. What is the ratio of the Cost (as % of GNI) in Coal in 1991 to that in 1993?
Provide a short and direct response. 0.97. What is the ratio of the Cost (as % of GNI) in Minerals in 1991 to that in 1993?
Ensure brevity in your answer.  2.02. What is the ratio of the Cost (as % of GNI) in Energy in 1991 to that in 1993?
Provide a succinct answer. 1.11. What is the ratio of the Cost (as % of GNI) of Water in 1991 to that in 1993?
Your answer should be very brief. 1.21. What is the ratio of the Cost (as % of GNI) of Coal in 1991 to that in 1994?
Offer a terse response. 1.01. What is the ratio of the Cost (as % of GNI) in Minerals in 1991 to that in 1994?
Ensure brevity in your answer.  1.55. What is the ratio of the Cost (as % of GNI) in Energy in 1991 to that in 1994?
Make the answer very short. 1.32. What is the ratio of the Cost (as % of GNI) of Water in 1991 to that in 1994?
Offer a terse response. 1.4. What is the ratio of the Cost (as % of GNI) in Coal in 1991 to that in 1995?
Give a very brief answer. 1.05. What is the ratio of the Cost (as % of GNI) of Minerals in 1991 to that in 1995?
Offer a very short reply. 1.56. What is the ratio of the Cost (as % of GNI) in Energy in 1991 to that in 1995?
Ensure brevity in your answer.  1.33. What is the ratio of the Cost (as % of GNI) in Water in 1991 to that in 1995?
Give a very brief answer. 1.35. What is the ratio of the Cost (as % of GNI) in Coal in 1992 to that in 1993?
Keep it short and to the point. 0.97. What is the ratio of the Cost (as % of GNI) of Minerals in 1992 to that in 1993?
Keep it short and to the point. 1.59. What is the ratio of the Cost (as % of GNI) in Energy in 1992 to that in 1993?
Keep it short and to the point. 0.99. What is the ratio of the Cost (as % of GNI) of Water in 1992 to that in 1993?
Provide a short and direct response. 1.08. What is the ratio of the Cost (as % of GNI) of Coal in 1992 to that in 1994?
Your response must be concise. 1.02. What is the ratio of the Cost (as % of GNI) of Minerals in 1992 to that in 1994?
Provide a short and direct response. 1.22. What is the ratio of the Cost (as % of GNI) in Energy in 1992 to that in 1994?
Give a very brief answer. 1.16. What is the ratio of the Cost (as % of GNI) in Water in 1992 to that in 1994?
Provide a succinct answer. 1.25. What is the ratio of the Cost (as % of GNI) of Coal in 1992 to that in 1995?
Provide a succinct answer. 1.06. What is the ratio of the Cost (as % of GNI) in Minerals in 1992 to that in 1995?
Your response must be concise. 1.23. What is the ratio of the Cost (as % of GNI) of Energy in 1992 to that in 1995?
Keep it short and to the point. 1.17. What is the ratio of the Cost (as % of GNI) in Water in 1992 to that in 1995?
Offer a very short reply. 1.21. What is the ratio of the Cost (as % of GNI) of Coal in 1993 to that in 1994?
Provide a succinct answer. 1.04. What is the ratio of the Cost (as % of GNI) in Minerals in 1993 to that in 1994?
Ensure brevity in your answer.  0.77. What is the ratio of the Cost (as % of GNI) in Energy in 1993 to that in 1994?
Your answer should be compact. 1.18. What is the ratio of the Cost (as % of GNI) in Water in 1993 to that in 1994?
Offer a very short reply. 1.16. What is the ratio of the Cost (as % of GNI) of Coal in 1993 to that in 1995?
Your answer should be very brief. 1.09. What is the ratio of the Cost (as % of GNI) in Minerals in 1993 to that in 1995?
Make the answer very short. 0.78. What is the ratio of the Cost (as % of GNI) in Energy in 1993 to that in 1995?
Your answer should be very brief. 1.19. What is the ratio of the Cost (as % of GNI) of Water in 1993 to that in 1995?
Your response must be concise. 1.12. What is the ratio of the Cost (as % of GNI) in Coal in 1994 to that in 1995?
Offer a terse response. 1.04. What is the ratio of the Cost (as % of GNI) of Minerals in 1994 to that in 1995?
Keep it short and to the point. 1.01. What is the ratio of the Cost (as % of GNI) of Energy in 1994 to that in 1995?
Offer a terse response. 1.01. What is the ratio of the Cost (as % of GNI) of Water in 1994 to that in 1995?
Ensure brevity in your answer.  0.97. What is the difference between the highest and the second highest Cost (as % of GNI) of Coal?
Give a very brief answer. 0.04. What is the difference between the highest and the second highest Cost (as % of GNI) in Minerals?
Your answer should be very brief. 0.14. What is the difference between the highest and the second highest Cost (as % of GNI) in Energy?
Give a very brief answer. 0.85. What is the difference between the highest and the second highest Cost (as % of GNI) in Water?
Your answer should be very brief. 0.77. What is the difference between the highest and the lowest Cost (as % of GNI) of Coal?
Your answer should be very brief. 0.13. What is the difference between the highest and the lowest Cost (as % of GNI) in Minerals?
Keep it short and to the point. 0.35. What is the difference between the highest and the lowest Cost (as % of GNI) in Energy?
Provide a short and direct response. 1.52. What is the difference between the highest and the lowest Cost (as % of GNI) in Water?
Your answer should be compact. 1.93. 